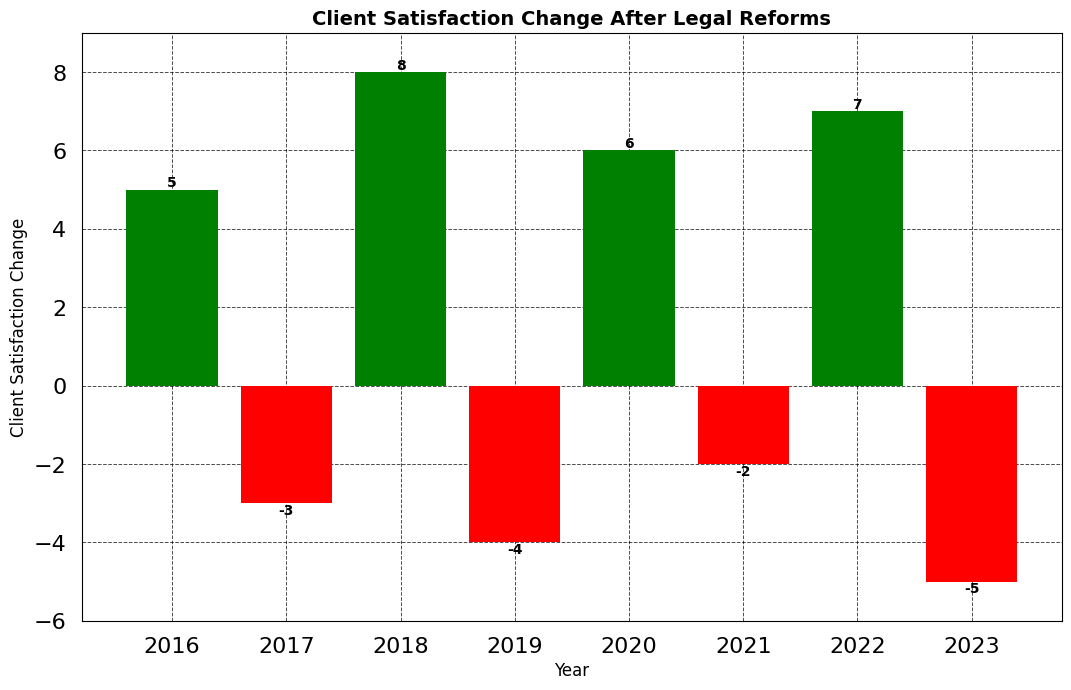How many years show a positive change in client satisfaction? Identify bars with green color (positive change). Count the green bars: 2016 (5), 2018 (8), 2020 (6), 2022 (7). Thus, there are 4 years with positive changes.
Answer: 4 Which year had the greatest increase in client satisfaction? Compare the heights of green bars. The tallest green bar is in 2018 with a value of 8.
Answer: 2018 What is the net change in client satisfaction from 2016 to 2023? Sum all the values: 5 (2016) - 3 (2017) + 8 (2018) - 4 (2019) + 6 (2020) - 2 (2021) + 7 (2022) - 5 (2023) = 12.
Answer: 12 Which year had the largest decrease in client satisfaction? Compare the heights of red bars. The tallest red bar, i.e., the most negative, is in 2023 with a value of -5.
Answer: 2023 What is the average change in client satisfaction over the years shown? Compute the average: (5 - 3 + 8 - 4 + 6 - 2 + 7 - 5) / 8. The sum is 12, so 12 / 8 = 1.5.
Answer: 1.5 How do the total positive changes compare to the total negative changes from 2016 to 2023? Calculate the sum of positive values: 5 + 8 + 6 + 7 = 26. Calculate the sum of negative values: -3 - 4 - 2 - 5 = -14. Compare 26 to -14.
Answer: Positive changes are greater Which two consecutive years saw the poorest change in client satisfaction overall? Find pairs of consecutive years and sum their changes: 2016-2017 (5 + -3 = 2), 2017-2018 (-3 + 8 = 5), 2018-2019 (8 + -4 = 4), 2019-2020 (-4 + 6 = 2), 2020-2021 (6 - 2 = 4), 2021-2022 (-2 + 7 = 5), 2022-2023 (7 - 5 = 2). The smallest overall change is 2.
Answer: 2016-2017, 2019-2020, 2022-2023 What is the total number of years showing a decrease in client satisfaction? Identify bars with red color (negative change). Count the red bars: 2017 (-3), 2019 (-4), 2021 (-2), 2023 (-5). Thus, there are 4 years with decreases.
Answer: 4 How many times did client satisfaction increase two years in a row? Identify periods of consecutive green bars: 2016-2017 (no), 2017-2018 (no), 2018-2019 (no), 2019-2020 (no), 2020-2021 (no), 2021-2022 (no), 2022-2023 (no). No two consecutive years of increase.
Answer: 0 